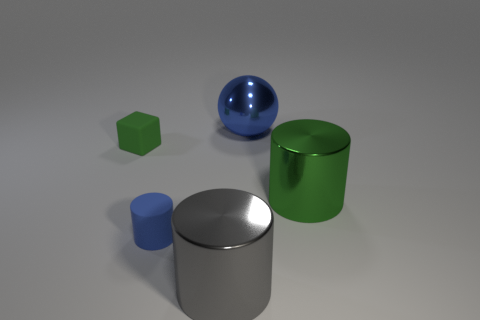What number of blue things have the same material as the tiny block?
Provide a short and direct response. 1. The cylinder that is left of the large metallic cylinder to the left of the big thing to the right of the ball is made of what material?
Keep it short and to the point. Rubber. There is a object that is right of the big blue shiny ball to the right of the blue rubber thing; what is its color?
Provide a succinct answer. Green. There is a cylinder that is the same size as the green block; what is its color?
Provide a short and direct response. Blue. How many small things are either gray metal objects or blue blocks?
Ensure brevity in your answer.  0. Are there more large gray cylinders that are on the left side of the small blue thing than green objects that are to the left of the small green thing?
Your response must be concise. No. What size is the thing that is the same color as the tiny matte cylinder?
Your answer should be compact. Large. How many other objects are the same size as the blue shiny sphere?
Your answer should be compact. 2. Are the tiny blue cylinder in front of the large green metallic thing and the large blue sphere made of the same material?
Keep it short and to the point. No. How many other objects are the same color as the small cube?
Offer a terse response. 1. 